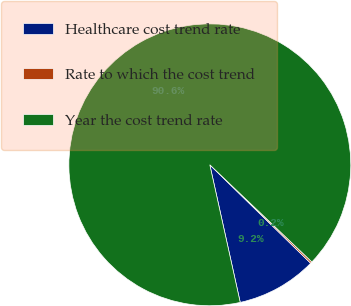Convert chart to OTSL. <chart><loc_0><loc_0><loc_500><loc_500><pie_chart><fcel>Healthcare cost trend rate<fcel>Rate to which the cost trend<fcel>Year the cost trend rate<nl><fcel>9.23%<fcel>0.2%<fcel>90.57%<nl></chart> 